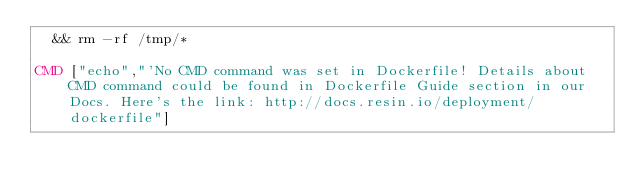<code> <loc_0><loc_0><loc_500><loc_500><_Dockerfile_>	&& rm -rf /tmp/*

CMD ["echo","'No CMD command was set in Dockerfile! Details about CMD command could be found in Dockerfile Guide section in our Docs. Here's the link: http://docs.resin.io/deployment/dockerfile"]
</code> 